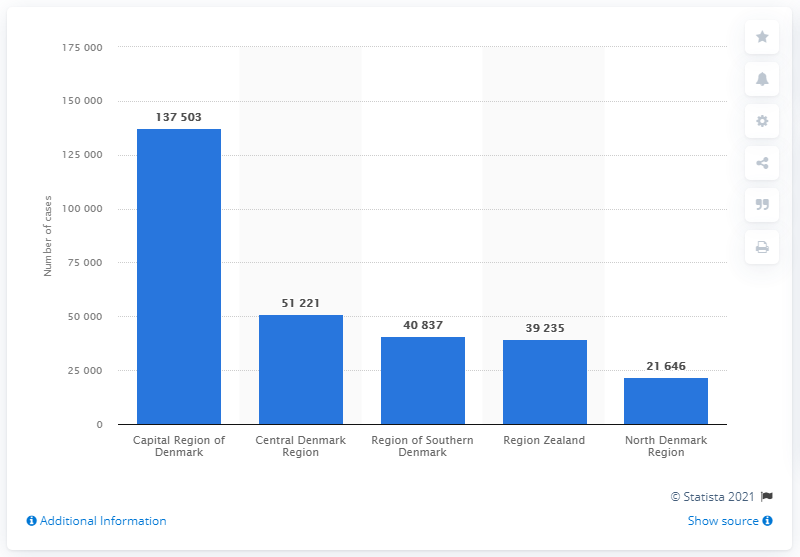Specify some key components in this picture. Central Denmark Region had the second highest number of confirmed cases of COVID-19. 